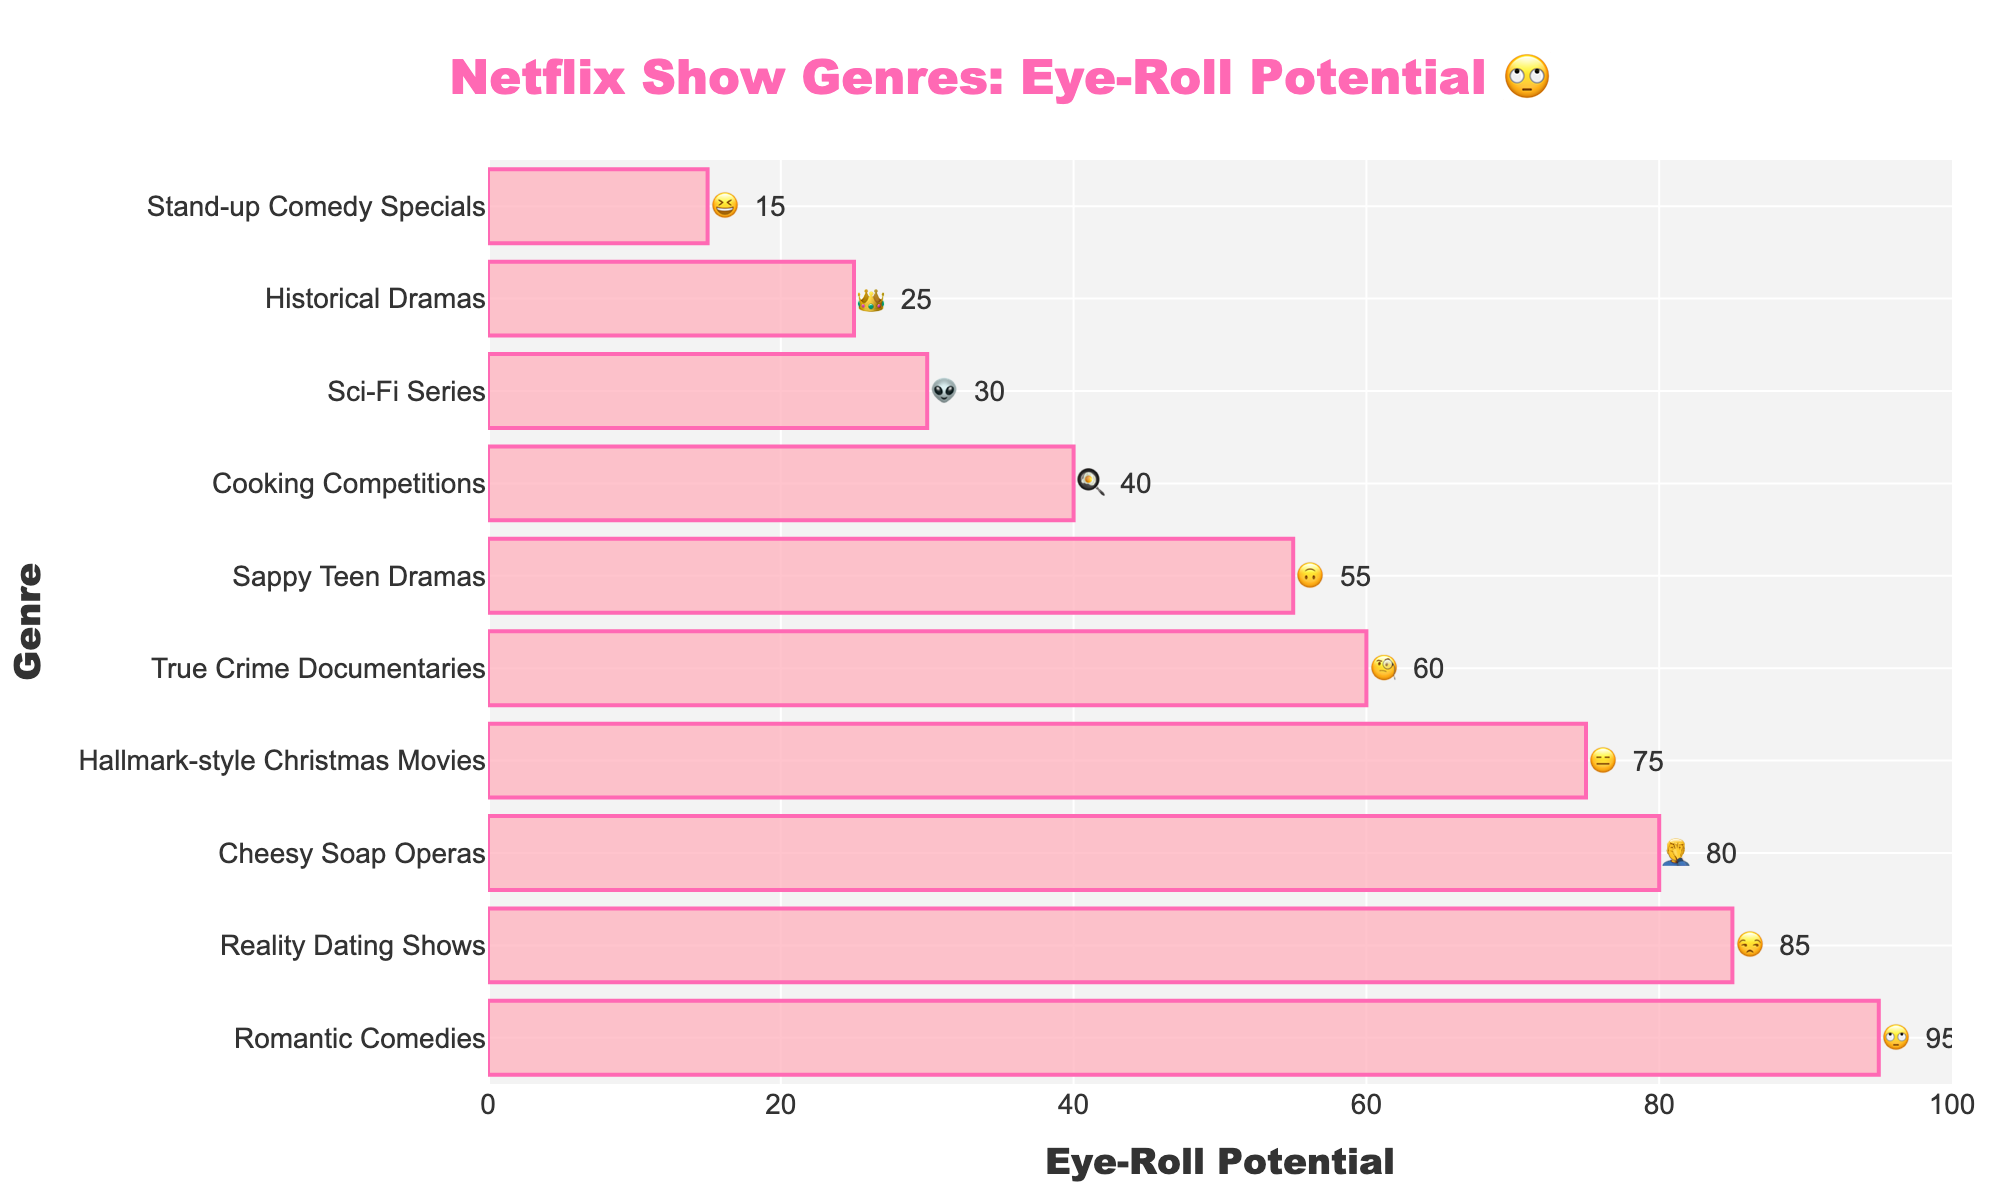what's the title of the chart? The title of the chart is displayed at the top and often gives a summary of what the chart is about. In this case, it’s centered at the top as "Netflix Show Genres: Eye-Roll Potential 🙄".
Answer: Netflix Show Genres: Eye-Roll Potential 🙄 which genre has the highest eye-roll potential? To find the genre with the highest eye-roll potential, look at the left-most bar and its corresponding label. The longest bar at the top corresponds to "Romantic Comedies" with an eye-roll potential of 95.
Answer: Romantic Comedies which genre has the lowest eye-roll potential? To find the genre with the lowest eye-roll potential, look at the right-most bar and its corresponding label. The shortest bar at the bottom corresponds to "Stand-up Comedy Specials" with an eye-roll potential of 15.
Answer: Stand-up Comedy Specials what's the eye-roll potential of Sci-Fi Series compared to that of True Crime Documentaries? Look at the relative length of bars for Sci-Fi Series and True Crime Documentaries. Sci-Fi Series has an eye-roll potential of 30, while True Crime Documentaries has 60. Therefore, Sci-Fi Series has a lower potential.
Answer: Sci-Fi Series is lower how much higher is eye-roll potential of Romantic Comedies than True Crime Documentaries? Subtract the eye-roll potential of True Crime Documentaries from that of Romantic Comedies. Romantic Comedies is 95, True Crime Documentaries is 60; thus, it's 95 - 60.
Answer: 35 how many genres have an eye-roll potential above 50? Count the number of genres with an eye-roll potential greater than 50 by observing the x-axis and corresponding bars. Genres above 50 are "Romantic Comedies", "Reality Dating Shows", "Cheesy Soap Operas", "Hallmark-style Christmas Movies", "True Crime Documentaries", and "Sappy Teen Dramas".
Answer: 6 what's the average eye-roll potential of all the genres? Sum up all eye-roll potentials and divide by the number of genres. The eye-roll potentials are: 95, 85, 80, 75, 60, 55, 40, 30, 25, 15; sum them up to get 560 and divide by 10.
Answer: 56 what genre ranks just below "Reality Dating Shows"? Look at the bar just below "Reality Dating Shows", which corresponds to the genre with slightly less eye-roll potential. It is "Cheesy Soap Operas".
Answer: Cheesy Soap Operas which genre elicited the emoji '🤦‍♂️'? Find the genre associated with each emoji. The '🤦‍♂️' emoji corresponds to "Cheesy Soap Operas".
Answer: Cheesy Soap Operas 